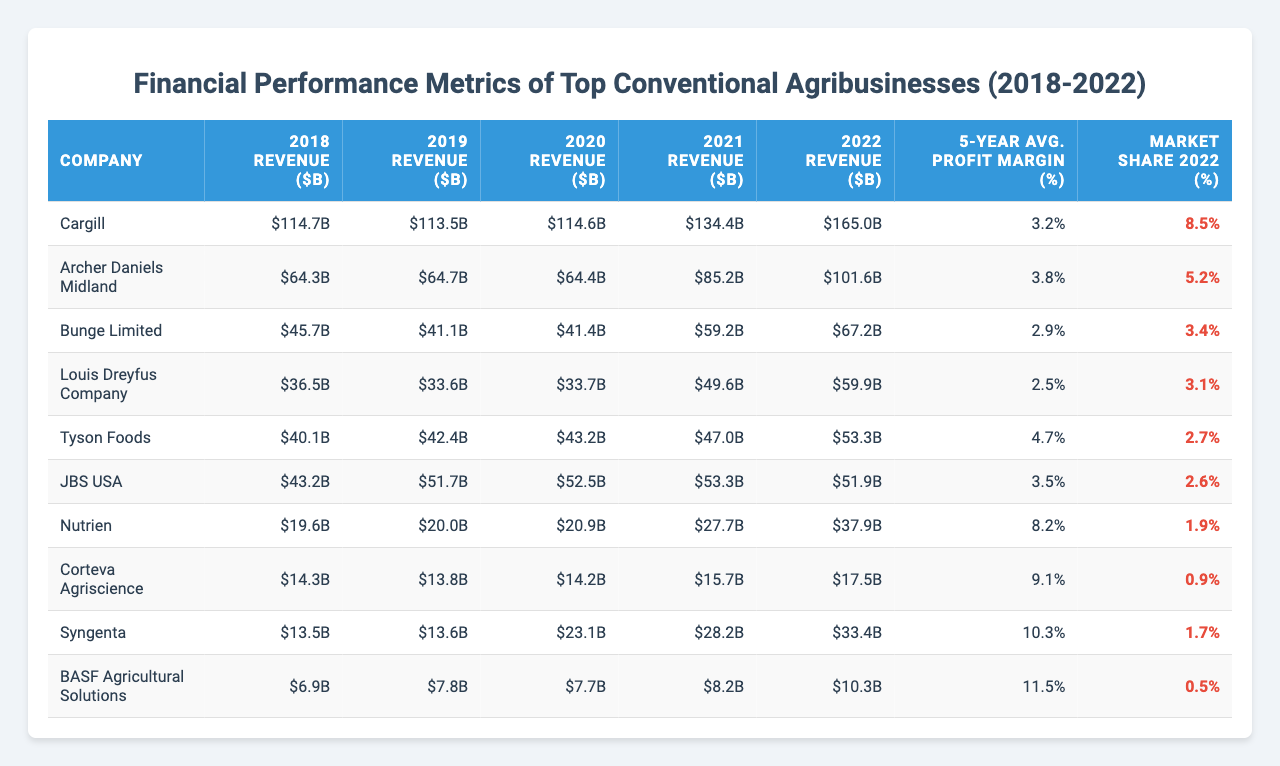What was Cargill's revenue in 2021? The table states that Cargill's revenue for 2021 is listed as $134.4 billion.
Answer: $134.4 billion Which company had the highest average profit margin over the past five years? By checking the "5-Year Avg. Profit Margin" column, Syngenta has the highest figure at 10.3%.
Answer: Syngenta What is the total revenue of Archer Daniels Midland over the past five years? Adding Archer Daniels Midland's revenues: 64.3 + 64.7 + 64.4 + 85.2 + 101.6 = 380.2 billion.
Answer: $380.2 billion Is the market share of JBS USA greater than 3% in 2022? The table shows JBS USA's market share as 2.6%, which is less than 3%.
Answer: No What company had the lowest revenue in 2019? By looking at the 2019 Revenue column, BASF Agricultural Solutions had the lowest revenue at $7.8 billion.
Answer: BASF Agricultural Solutions What is the difference in market share between Cargill and Bunge Limited in 2022? Cargill's market share is 8.5% and Bunge Limited's is 3.4%. The difference is 8.5% - 3.4% = 5.1%.
Answer: 5.1% Which company experienced a revenue increase from 2018 to 2022? Checking each company’s revenues, Cargill increased from $114.7 billion in 2018 to $165.0 billion in 2022.
Answer: Cargill What is the average annual revenue growth rate for Tyson Foods from 2018 to 2022? Tyson Foods' revenue increased from $40.1 billion in 2018 to $53.3 billion in 2022. The growth rate is calculated as ((53.3/40.1)^(1/4)-1) x 100 = approximately 7.1%.
Answer: 7.1% Did Nutrien's revenue surpass $30 billion in any of the provided years? In the table, Nutrien's highest revenue is $37.9 billion in 2022, which is over $30 billion.
Answer: Yes Which two companies have the closest revenues in 2020? Comparing revenues in 2020, Bunge Limited had $41.4 billion and Louis Dreyfus Company had $33.7 billion. The closest pair is Bunge and Louis Dreyfus with a gap of $7.7 billion.
Answer: Bunge Limited and Louis Dreyfus Company 